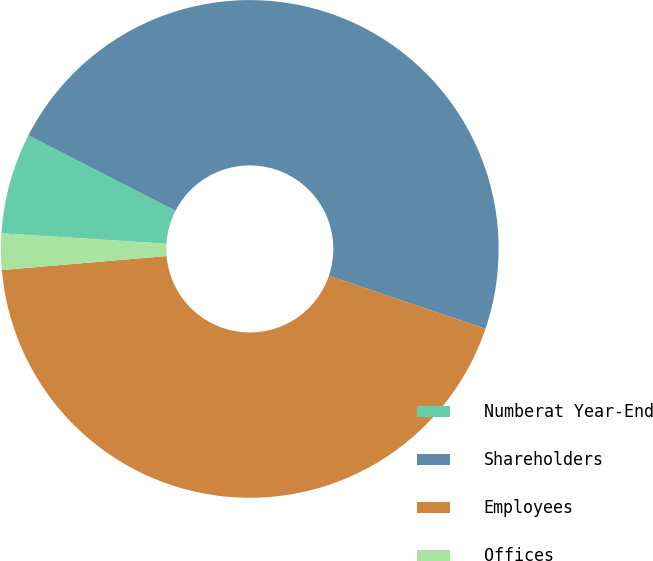Convert chart. <chart><loc_0><loc_0><loc_500><loc_500><pie_chart><fcel>Numberat Year-End<fcel>Shareholders<fcel>Employees<fcel>Offices<nl><fcel>6.55%<fcel>47.65%<fcel>43.45%<fcel>2.35%<nl></chart> 